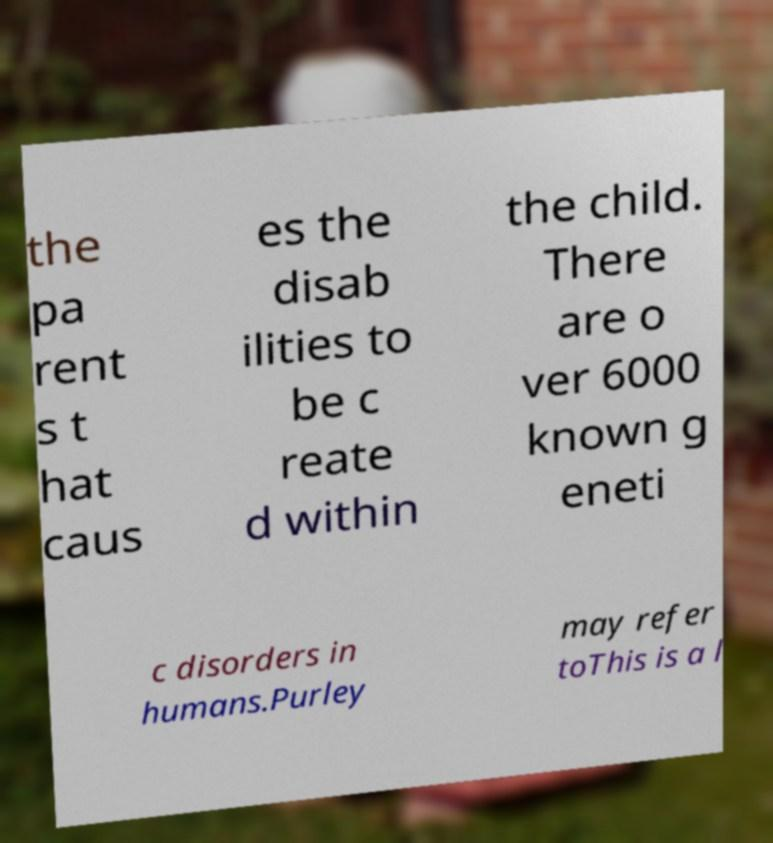Can you accurately transcribe the text from the provided image for me? the pa rent s t hat caus es the disab ilities to be c reate d within the child. There are o ver 6000 known g eneti c disorders in humans.Purley may refer toThis is a l 